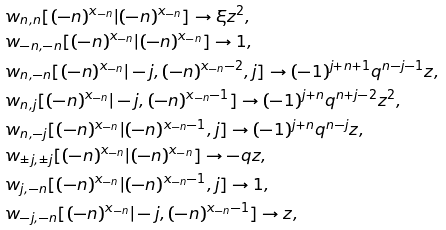Convert formula to latex. <formula><loc_0><loc_0><loc_500><loc_500>& w _ { n , n } [ ( - n ) ^ { x _ { - n } } | ( - n ) ^ { x _ { - n } } ] \to \xi z ^ { 2 } , \\ & w _ { - n , - n } [ ( - n ) ^ { x _ { - n } } | ( - n ) ^ { x _ { - n } } ] \to 1 , \\ & w _ { n , - n } [ ( - n ) ^ { x _ { - n } } | - j , ( - n ) ^ { x _ { - n } - 2 } , j ] \to ( - 1 ) ^ { j + n + 1 } q ^ { n - j - 1 } z , \\ & w _ { n , j } [ ( - n ) ^ { x _ { - n } } | - j , ( - n ) ^ { x _ { - n } - 1 } ] \to ( - 1 ) ^ { j + n } q ^ { n + j - 2 } z ^ { 2 } , \\ & w _ { n , - j } [ ( - n ) ^ { x _ { - n } } | ( - n ) ^ { x _ { - n } - 1 } , j ] \to ( - 1 ) ^ { j + n } q ^ { n - j } z , \\ & w _ { \pm j , \pm j } [ ( - n ) ^ { x _ { - n } } | ( - n ) ^ { x _ { - n } } ] \to - q z , \\ & w _ { j , - n } [ ( - n ) ^ { x _ { - n } } | ( - n ) ^ { x _ { - n } - 1 } , j ] \to 1 , \\ & w _ { - j , - n } [ ( - n ) ^ { x _ { - n } } | - j , ( - n ) ^ { x _ { - n } - 1 } ] \to z ,</formula> 